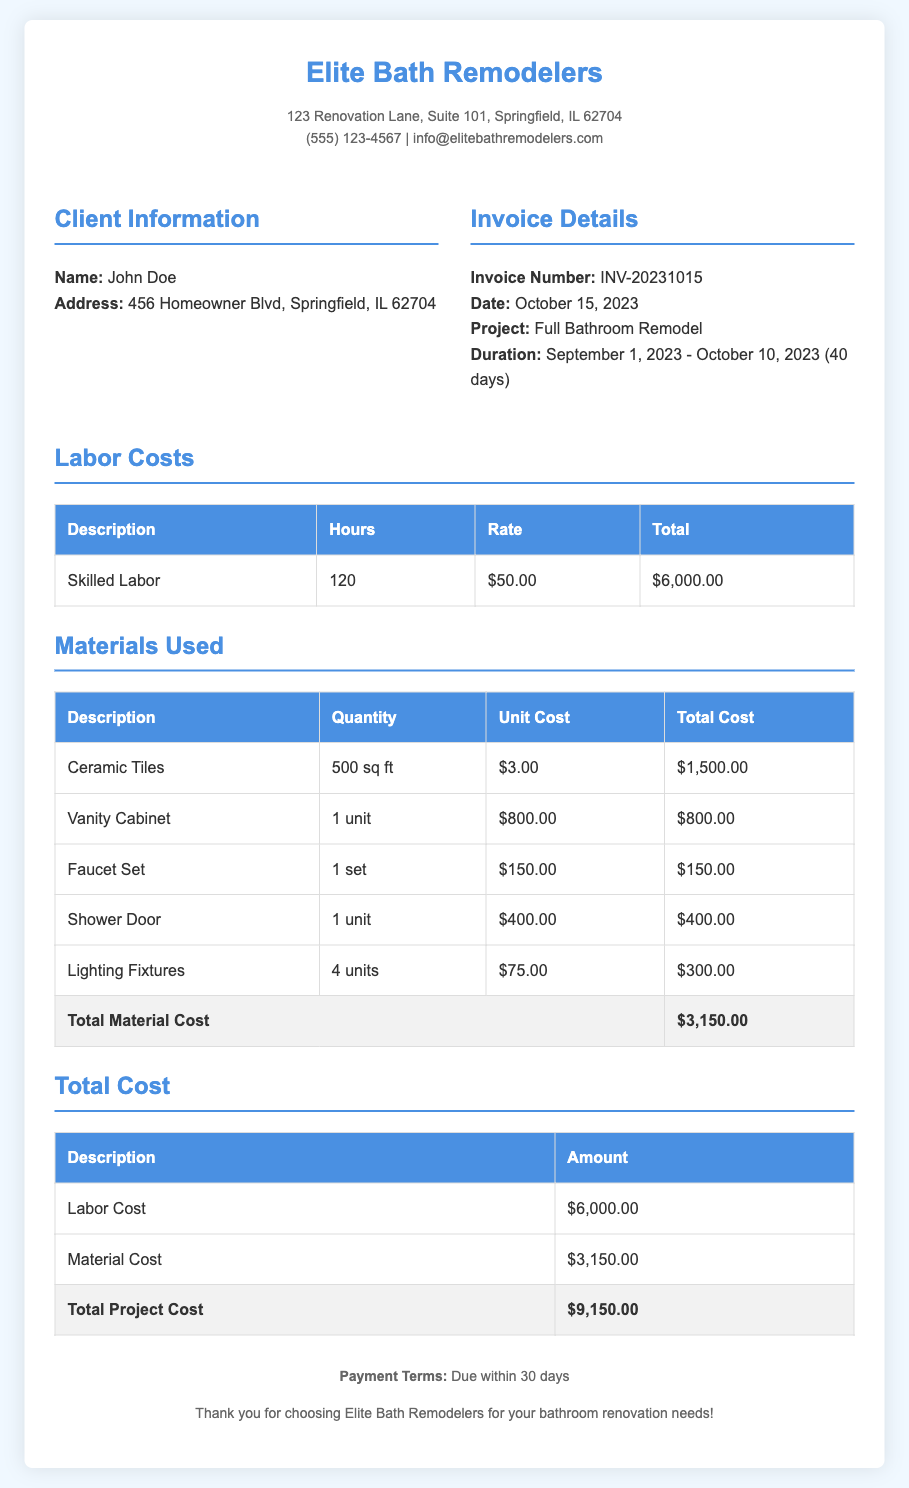What is the invoice number? The invoice number is specified in the document as the unique identifier for this transaction.
Answer: INV-20231015 Who is the client? The client is named in the document, which provides their personal information.
Answer: John Doe What is the project duration? The project duration is listed in the invoice details section, indicating the start and end dates of the remodeling work.
Answer: September 1, 2023 - October 10, 2023 (40 days) What is the total labor cost? The total labor cost is calculated based on the hours worked and the rate, found in the labor costs table.
Answer: $6,000.00 How many square feet of ceramic tiles were used? The quantity of ceramic tiles used is mentioned in the materials used section of the document.
Answer: 500 sq ft What is the total project cost? The total project cost is the sum of labor and material costs detailed in the invoice.
Answer: $9,150.00 Which material cost is the highest? This requires reasoning over the material costs listed to identify the most expensive item.
Answer: Vanity Cabinet When is the payment due? The payment terms state the expected time frame for when payment should be completed.
Answer: Due within 30 days What is the unit cost of the faucet set? The unit cost can be found in the materials used table, specifically for the faucet set.
Answer: $150.00 How many lighting fixtures were included in the remodel? This information is retrieved from the materials used table detailing the items involved in the project.
Answer: 4 units 